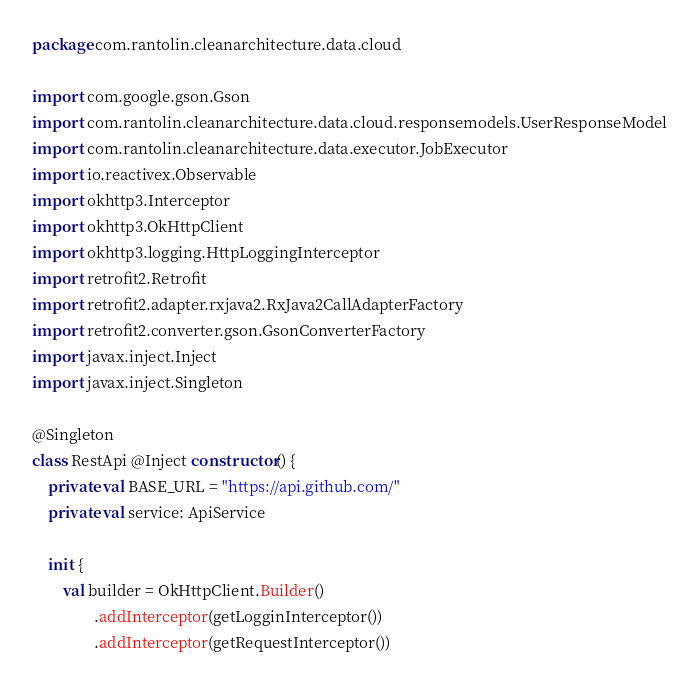<code> <loc_0><loc_0><loc_500><loc_500><_Kotlin_>package com.rantolin.cleanarchitecture.data.cloud

import com.google.gson.Gson
import com.rantolin.cleanarchitecture.data.cloud.responsemodels.UserResponseModel
import com.rantolin.cleanarchitecture.data.executor.JobExecutor
import io.reactivex.Observable
import okhttp3.Interceptor
import okhttp3.OkHttpClient
import okhttp3.logging.HttpLoggingInterceptor
import retrofit2.Retrofit
import retrofit2.adapter.rxjava2.RxJava2CallAdapterFactory
import retrofit2.converter.gson.GsonConverterFactory
import javax.inject.Inject
import javax.inject.Singleton

@Singleton
class RestApi @Inject constructor() {
    private val BASE_URL = "https://api.github.com/"
    private val service: ApiService

    init {
        val builder = OkHttpClient.Builder()
                .addInterceptor(getLogginInterceptor())
                .addInterceptor(getRequestInterceptor())</code> 